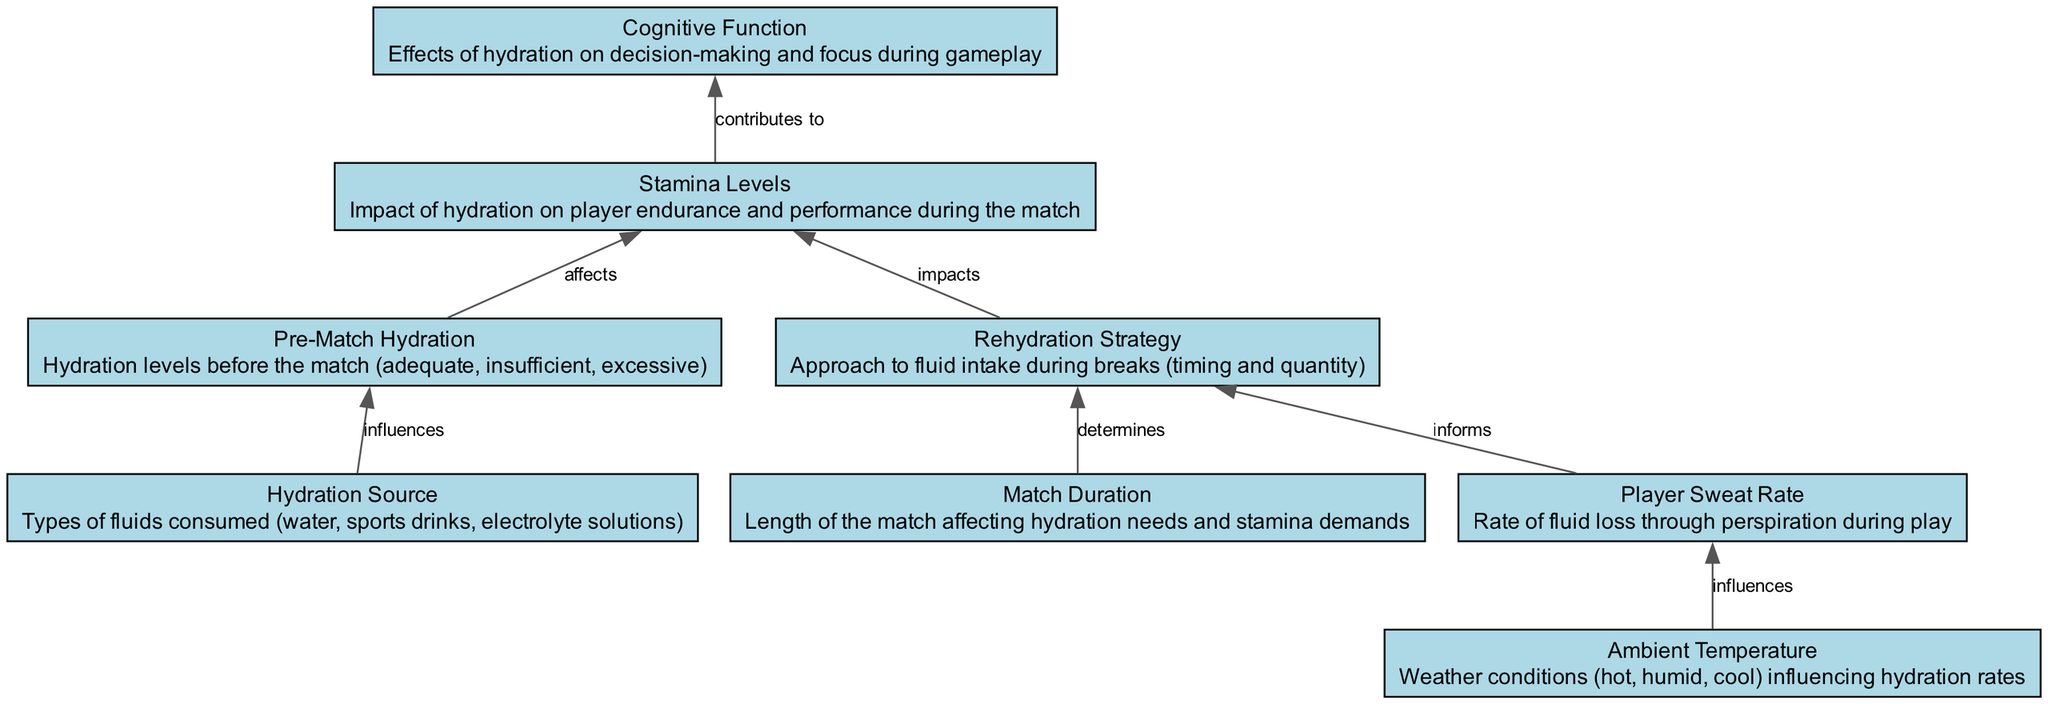How many elements are in the diagram? The diagram contains a total of eight elements that detail the impact of hydration levels on player stamina during matches.
Answer: 8 What is the relationship between "Pre-Match Hydration" and "Stamina Levels"? "Pre-Match Hydration" influences the "Stamina Levels," indicating that how well players are hydrated before the match can affect their stamina during play.
Answer: influences Which element determines the "Rehydration Strategy"? "Match Duration" is the element that determines the "Rehydration Strategy," meaning the length of the match dictates how players should rehydrate during breaks.
Answer: Match Duration What influences the "Player Sweat Rate"? "Ambient Temperature" influences the "Player Sweat Rate," suggesting that weather conditions impact how much players sweat during the match.
Answer: Ambient Temperature How does "Hydration Source" affect "Cognitive Function"? The "Hydration Source" indirectly impacts "Cognitive Function" by influencing "Stamina Levels," which contributes to cognitive abilities during gameplay, thus requiring multiple reasoning steps to connect these nodes.
Answer: contributes to What node does "Rehydration Strategy" connect to? "Rehydration Strategy" connects to "Stamina Levels," which indicates that the strategies employed for rehydration impact player stamina during the match.
Answer: Stamina Levels What is the flow direction of the relationship linking "Player Sweat Rate" to "Rehydration Strategy"? The relationship flows from "Player Sweat Rate" to "Rehydration Strategy," indicating that the rate of fluid loss through sweat informs how players should rehydrate.
Answer: informs Which element will directly influence "Cognitive Function"? "Stamina Levels" directly influence "Cognitive Function," as the endurance and overall performance of players during the match can affect their decision-making and focus.
Answer: Stamina Levels 